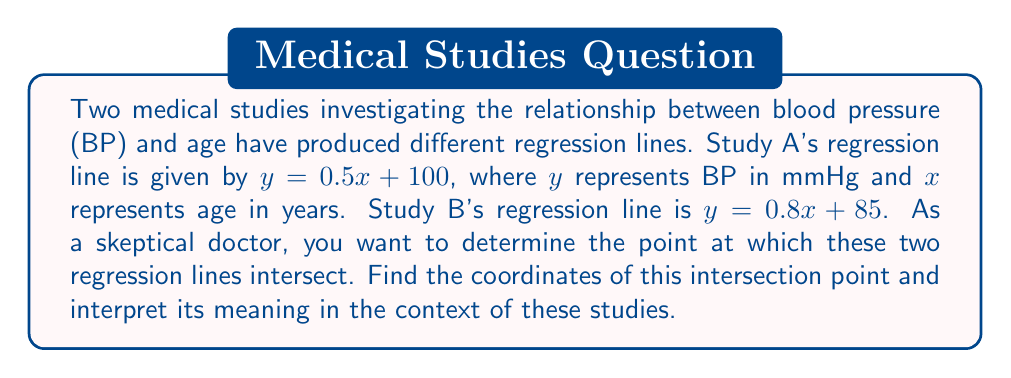Can you solve this math problem? To find the intersection point of two lines, we need to solve the system of equations formed by the two regression lines:

$$\begin{cases}
y = 0.5x + 100 & \text{(Study A)}\\
y = 0.8x + 85 & \text{(Study B)}
\end{cases}$$

At the intersection point, the $y$ values are equal, so we can set the right-hand sides of these equations equal to each other:

$$0.5x + 100 = 0.8x + 85$$

Now, let's solve for $x$:

$$0.5x - 0.8x = 85 - 100$$
$$-0.3x = -15$$
$$x = 50$$

To find the $y$ coordinate, we can substitute $x = 50$ into either of the original equations. Let's use Study A's equation:

$$y = 0.5(50) + 100 = 25 + 100 = 125$$

Therefore, the intersection point is $(50, 125)$.

Interpretation:
The intersection point $(50, 125)$ means that at age 50, both studies predict a blood pressure of 125 mmHg. This is the only point where the two studies agree. For ages below 50, Study A predicts higher blood pressure than Study B, while for ages above 50, Study B predicts higher blood pressure than Study A.

As a skeptical doctor, you might question:
1. Why do these studies diverge for ages other than 50?
2. What methodological differences could account for these discrepancies?
3. Which study might be more reliable, and why?
4. How should these conflicting results be interpreted in clinical practice?

These questions highlight the importance of critically evaluating statistical approaches in medical research and understanding the limitations of regression analyses in predicting complex physiological relationships.
Answer: The intersection point of the two regression lines is $(50, 125)$, meaning at age 50 years, both studies predict a blood pressure of 125 mmHg. 